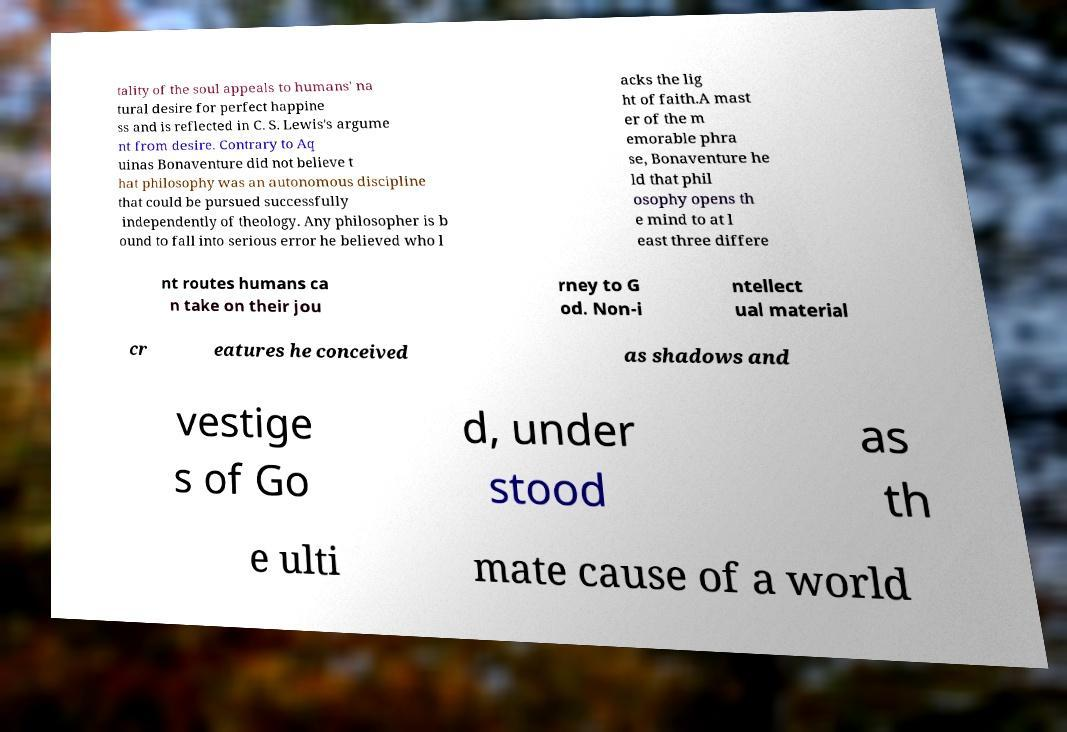For documentation purposes, I need the text within this image transcribed. Could you provide that? tality of the soul appeals to humans' na tural desire for perfect happine ss and is reflected in C. S. Lewis's argume nt from desire. Contrary to Aq uinas Bonaventure did not believe t hat philosophy was an autonomous discipline that could be pursued successfully independently of theology. Any philosopher is b ound to fall into serious error he believed who l acks the lig ht of faith.A mast er of the m emorable phra se, Bonaventure he ld that phil osophy opens th e mind to at l east three differe nt routes humans ca n take on their jou rney to G od. Non-i ntellect ual material cr eatures he conceived as shadows and vestige s of Go d, under stood as th e ulti mate cause of a world 